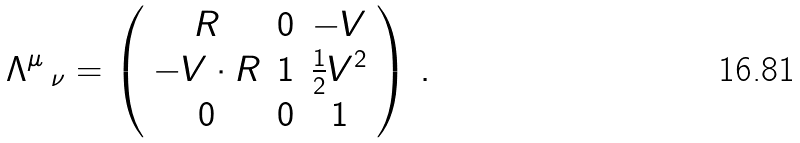Convert formula to latex. <formula><loc_0><loc_0><loc_500><loc_500>\Lambda ^ { \mu } \, _ { \nu } = \left ( \begin{array} { c c c } R & 0 & - V \\ - V \cdot R & 1 & \frac { 1 } { 2 } V ^ { 2 } \\ 0 & 0 & 1 \\ \end{array} \right ) \, .</formula> 